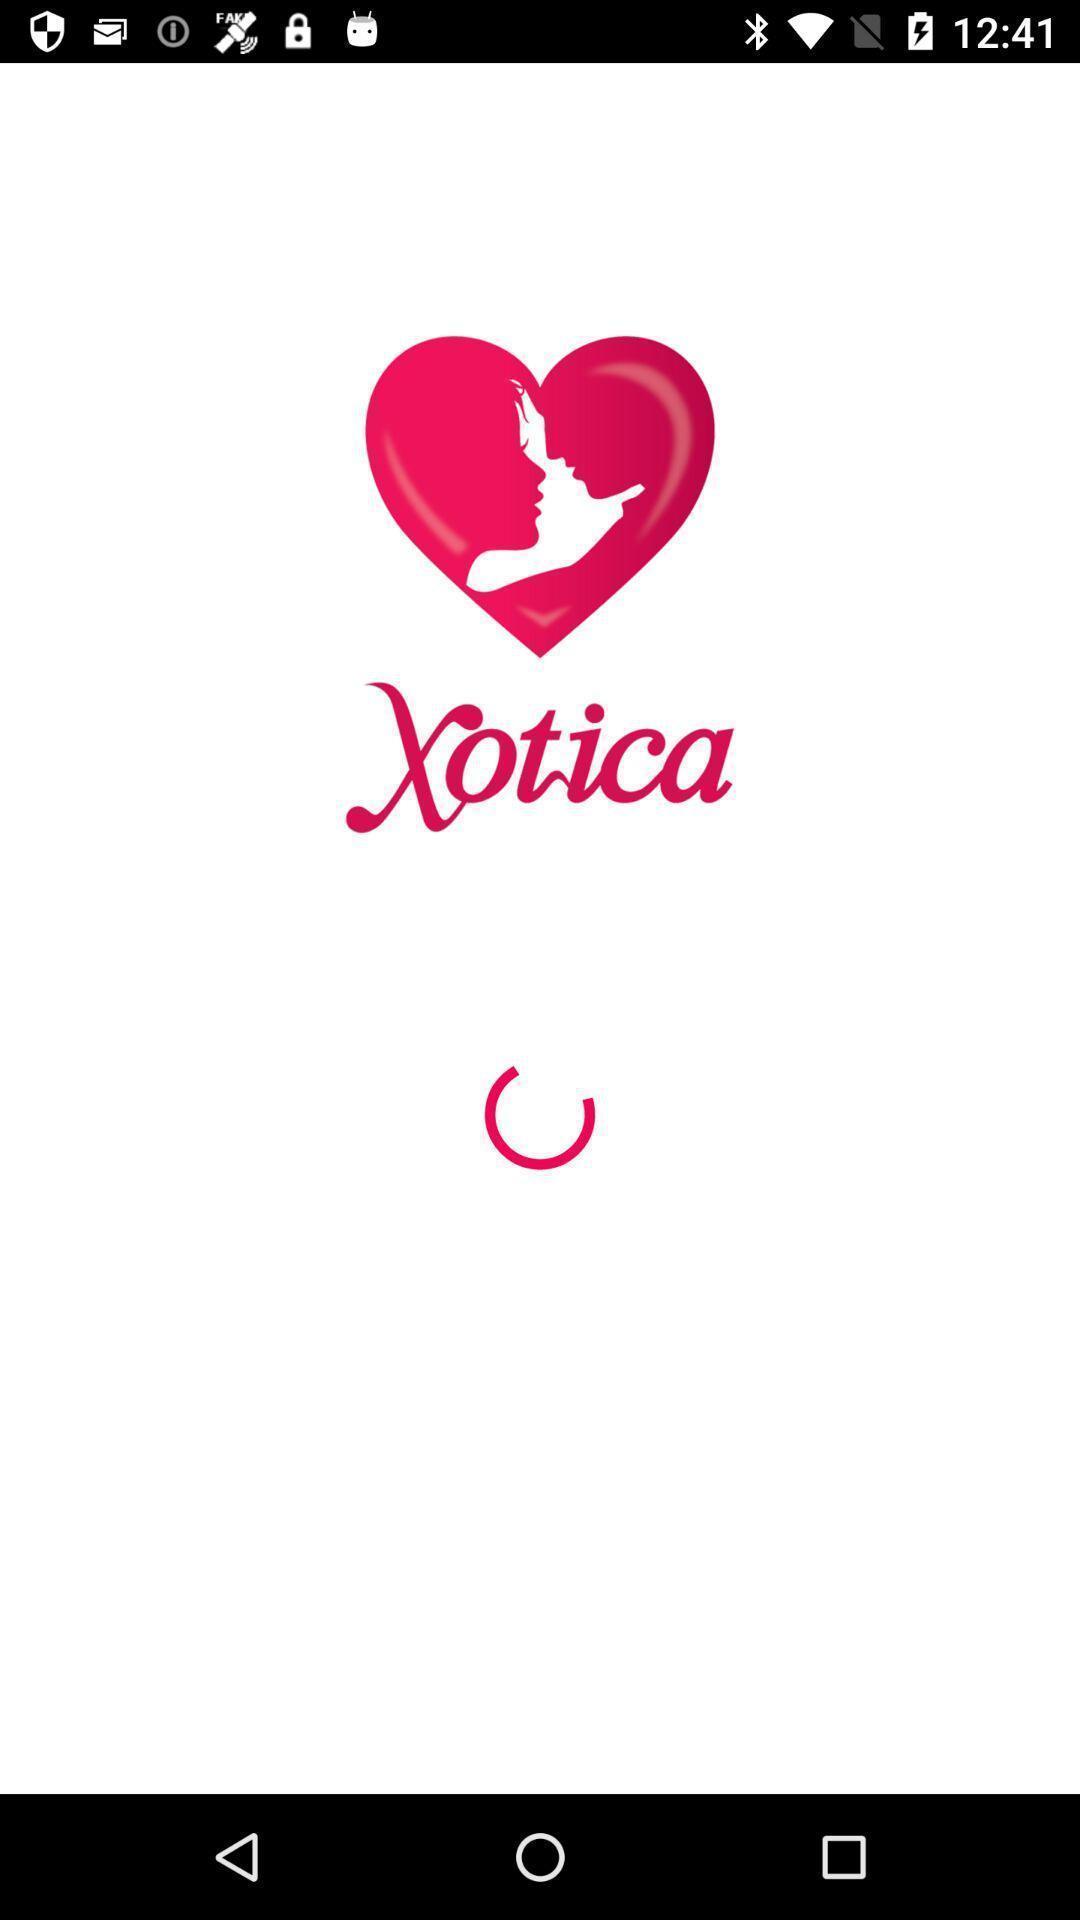Describe the key features of this screenshot. Welcome page. 